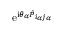Convert formula to latex. <formula><loc_0><loc_0><loc_500><loc_500>e ^ { i \theta _ { \alpha } \hat { P } _ { i _ { \alpha } j _ { \alpha } } }</formula> 